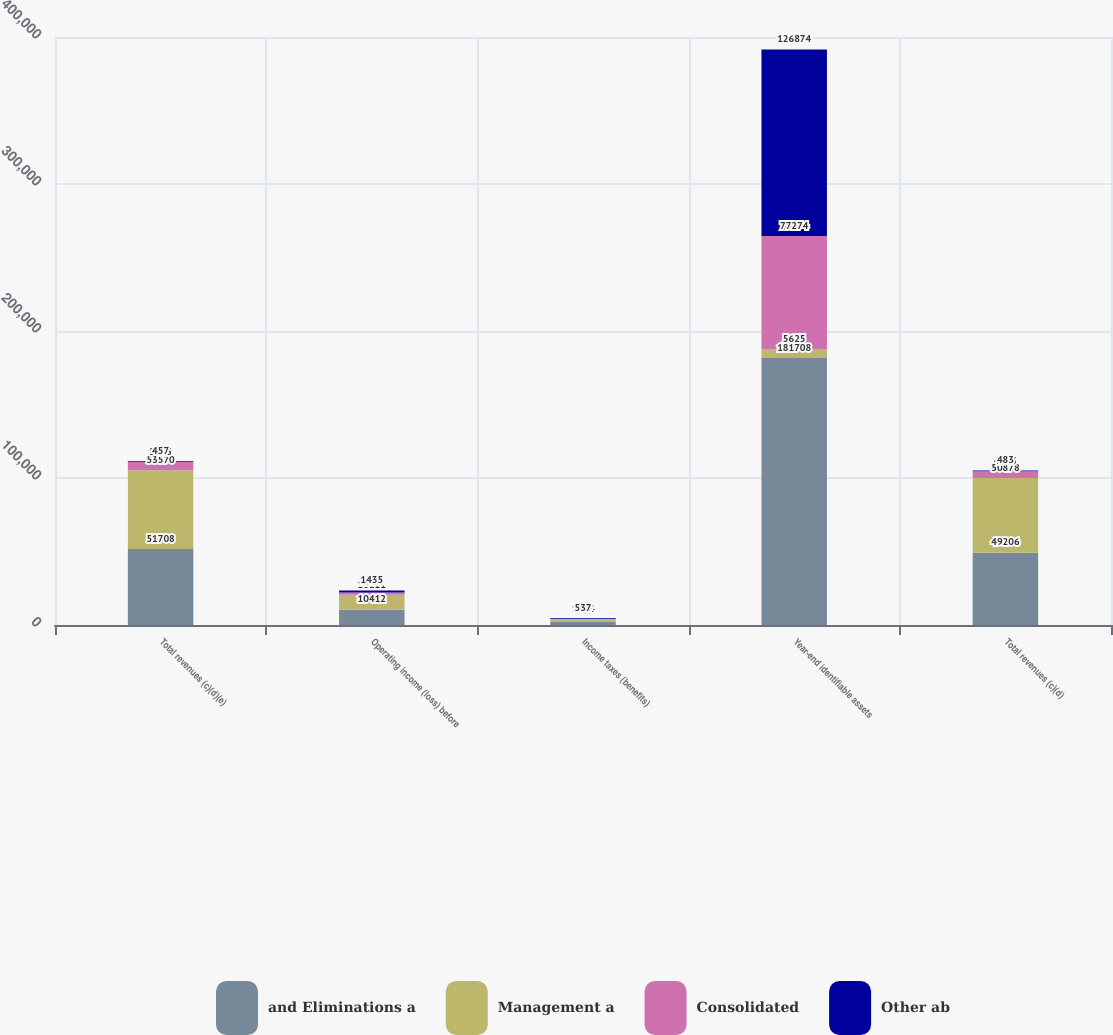Convert chart to OTSL. <chart><loc_0><loc_0><loc_500><loc_500><stacked_bar_chart><ecel><fcel>Total revenues (c)(d)(e)<fcel>Operating income (loss) before<fcel>Income taxes (benefits)<fcel>Year-end identifiable assets<fcel>Total revenues (c)(d)<nl><fcel>and Eliminations a<fcel>51708<fcel>10412<fcel>2393<fcel>181708<fcel>49206<nl><fcel>Management a<fcel>53570<fcel>10121<fcel>1494<fcel>5625<fcel>50878<nl><fcel>Consolidated<fcel>5625<fcel>1538<fcel>334<fcel>77274<fcel>4543<nl><fcel>Other ab<fcel>457<fcel>1435<fcel>537<fcel>126874<fcel>483<nl></chart> 